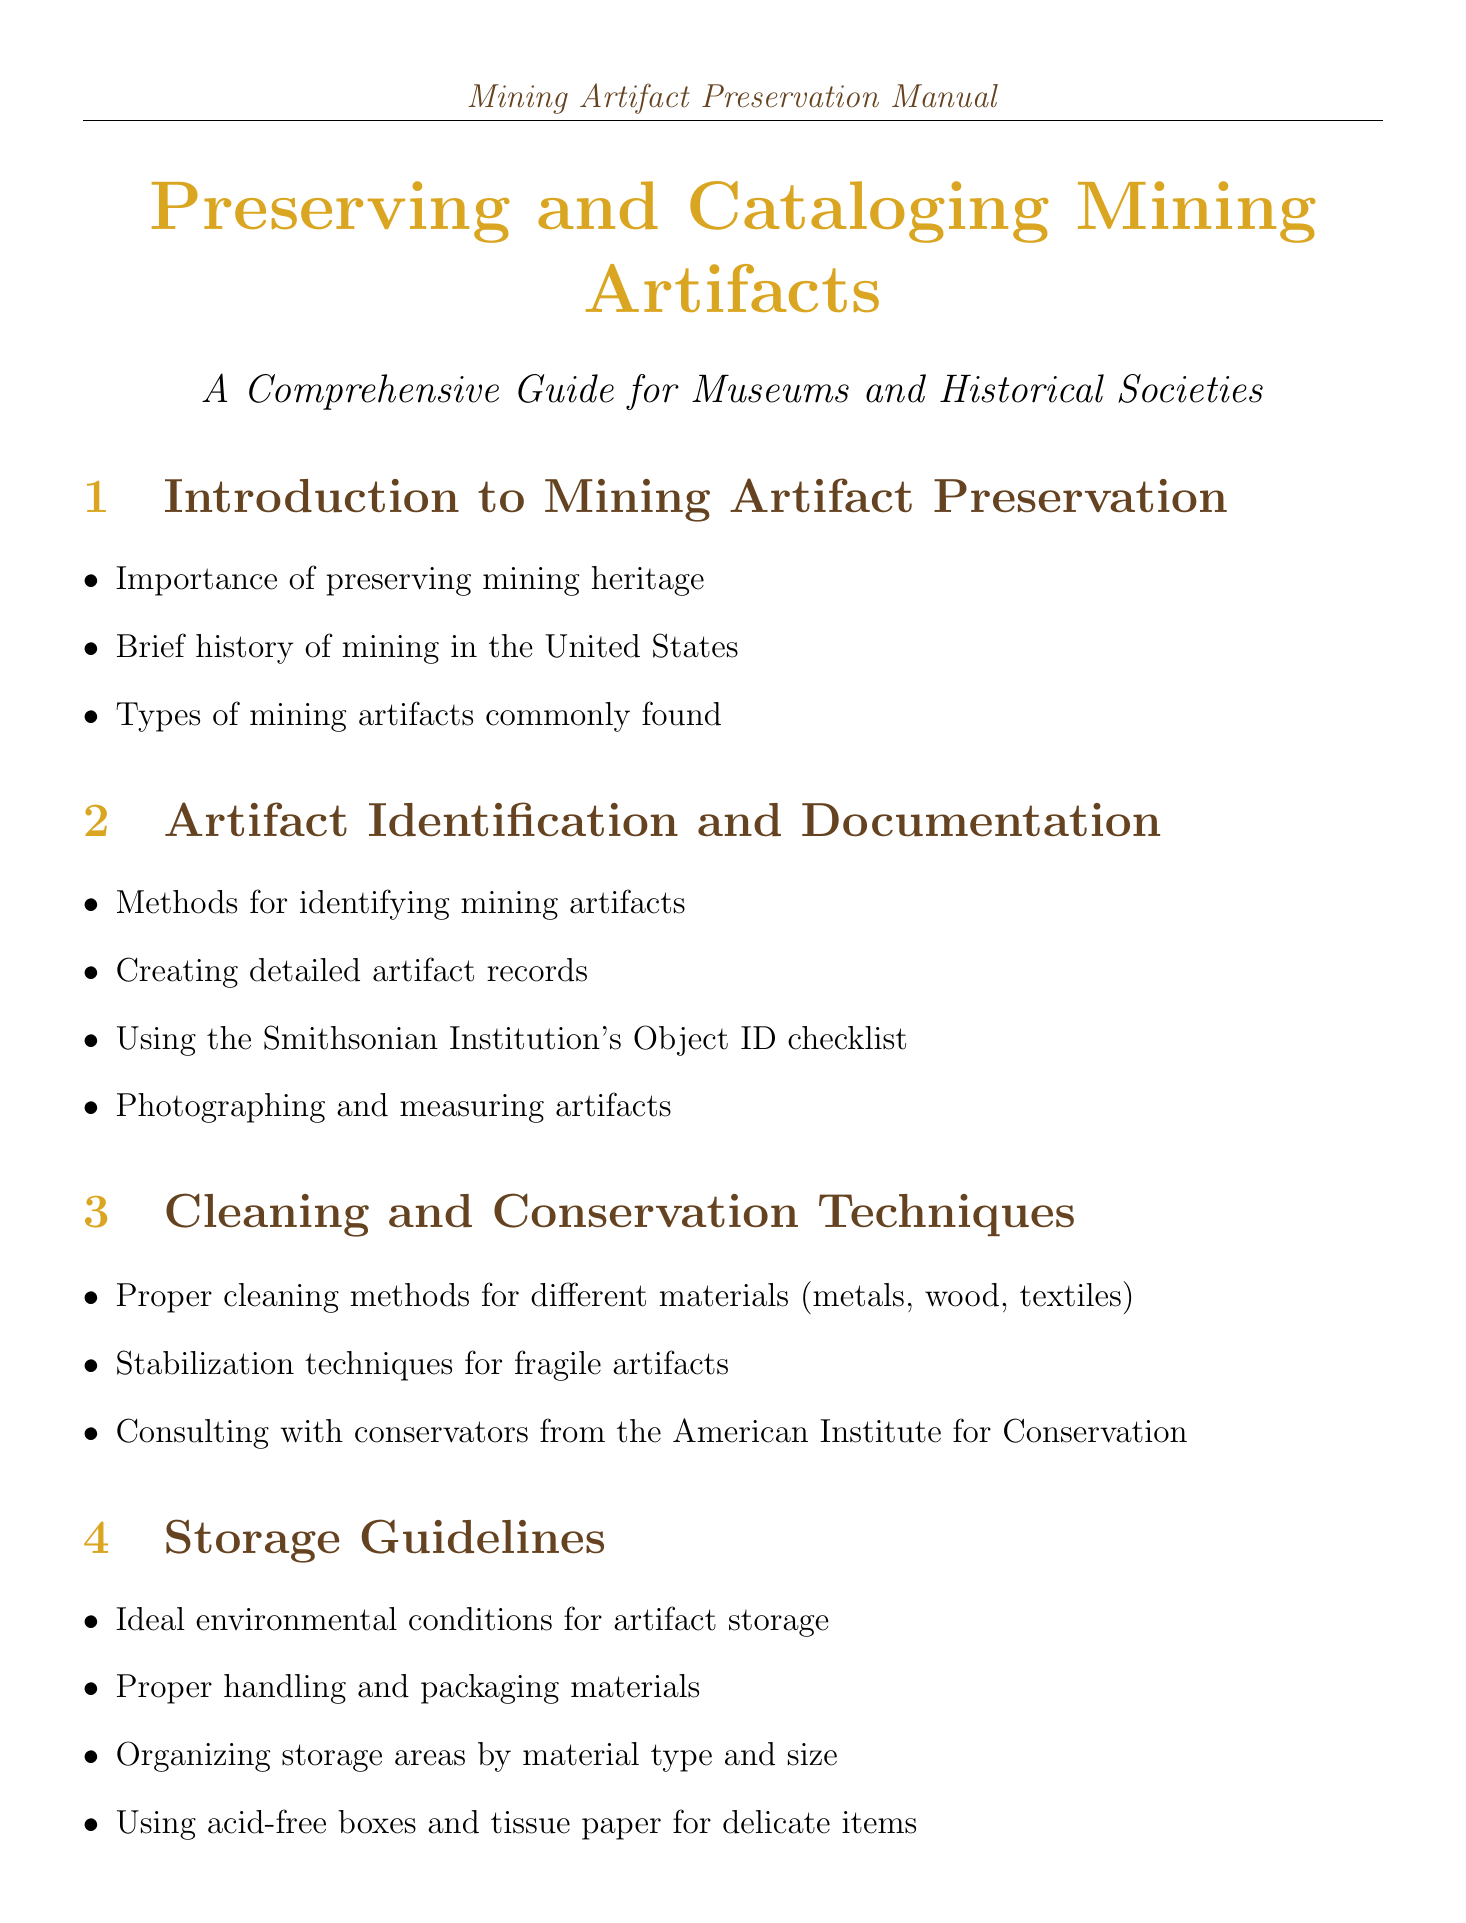What are the types of mining artifacts commonly found? The document includes a specific section that outlines types of mining artifacts, which are discussed under "Introduction to Mining Artifact Preservation."
Answer: Types of mining artifacts commonly found What is the purpose of the Smithsonian Institution's Object ID checklist? This checklist is mentioned in the "Artifact Identification and Documentation" section as a tool for creating detailed artifact records.
Answer: Creating detailed artifact records What is recommended for cleaning fragile artifacts? The "Cleaning and Conservation Techniques" section discusses stabilization techniques as part of cleaning methods for fragile artifacts.
Answer: Stabilization techniques What are the ideal conditions for artifact storage? The "Storage Guidelines" section mentions ideal environmental conditions that should be followed for artifact storage.
Answer: Ideal environmental conditions What should be included in an emergency response plan? The "Disaster Preparedness and Recovery" section outlines what an emergency response plan should entail, indicating various protections needed.
Answer: An emergency response plan What is a thesaurus in the context of this manual? The "Cataloging Systems" section defines a thesaurus as a controlled vocabulary for consistent cataloging of artifacts.
Answer: Controlled vocabulary What legal compliance is mentioned regarding the collection of mining artifacts? The "Legal and Ethical Considerations" section addresses compliance with specific legal acts related to artifacts.
Answer: Archaeological Resources Protection Act How many case studies are included in the manual? The number of case studies listed in the manual is stated explicitly in the "Case Studies" section.
Answer: Two What is the focus of the resource provided by the Society for Industrial Archeology? This resource is mentioned in the "Resources" section and pertains to the guidance offered for preserving industrial artifacts.
Answer: Preserving industrial artifacts 